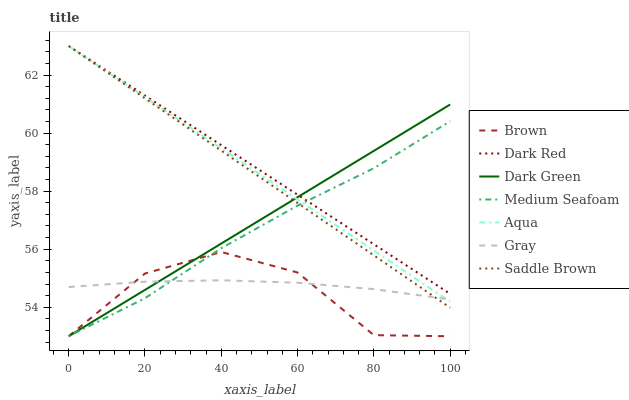Does Brown have the minimum area under the curve?
Answer yes or no. Yes. Does Dark Red have the maximum area under the curve?
Answer yes or no. Yes. Does Gray have the minimum area under the curve?
Answer yes or no. No. Does Gray have the maximum area under the curve?
Answer yes or no. No. Is Dark Green the smoothest?
Answer yes or no. Yes. Is Brown the roughest?
Answer yes or no. Yes. Is Gray the smoothest?
Answer yes or no. No. Is Gray the roughest?
Answer yes or no. No. Does Brown have the lowest value?
Answer yes or no. Yes. Does Gray have the lowest value?
Answer yes or no. No. Does Saddle Brown have the highest value?
Answer yes or no. Yes. Does Gray have the highest value?
Answer yes or no. No. Is Gray less than Dark Red?
Answer yes or no. Yes. Is Dark Red greater than Gray?
Answer yes or no. Yes. Does Dark Red intersect Dark Green?
Answer yes or no. Yes. Is Dark Red less than Dark Green?
Answer yes or no. No. Is Dark Red greater than Dark Green?
Answer yes or no. No. Does Gray intersect Dark Red?
Answer yes or no. No. 